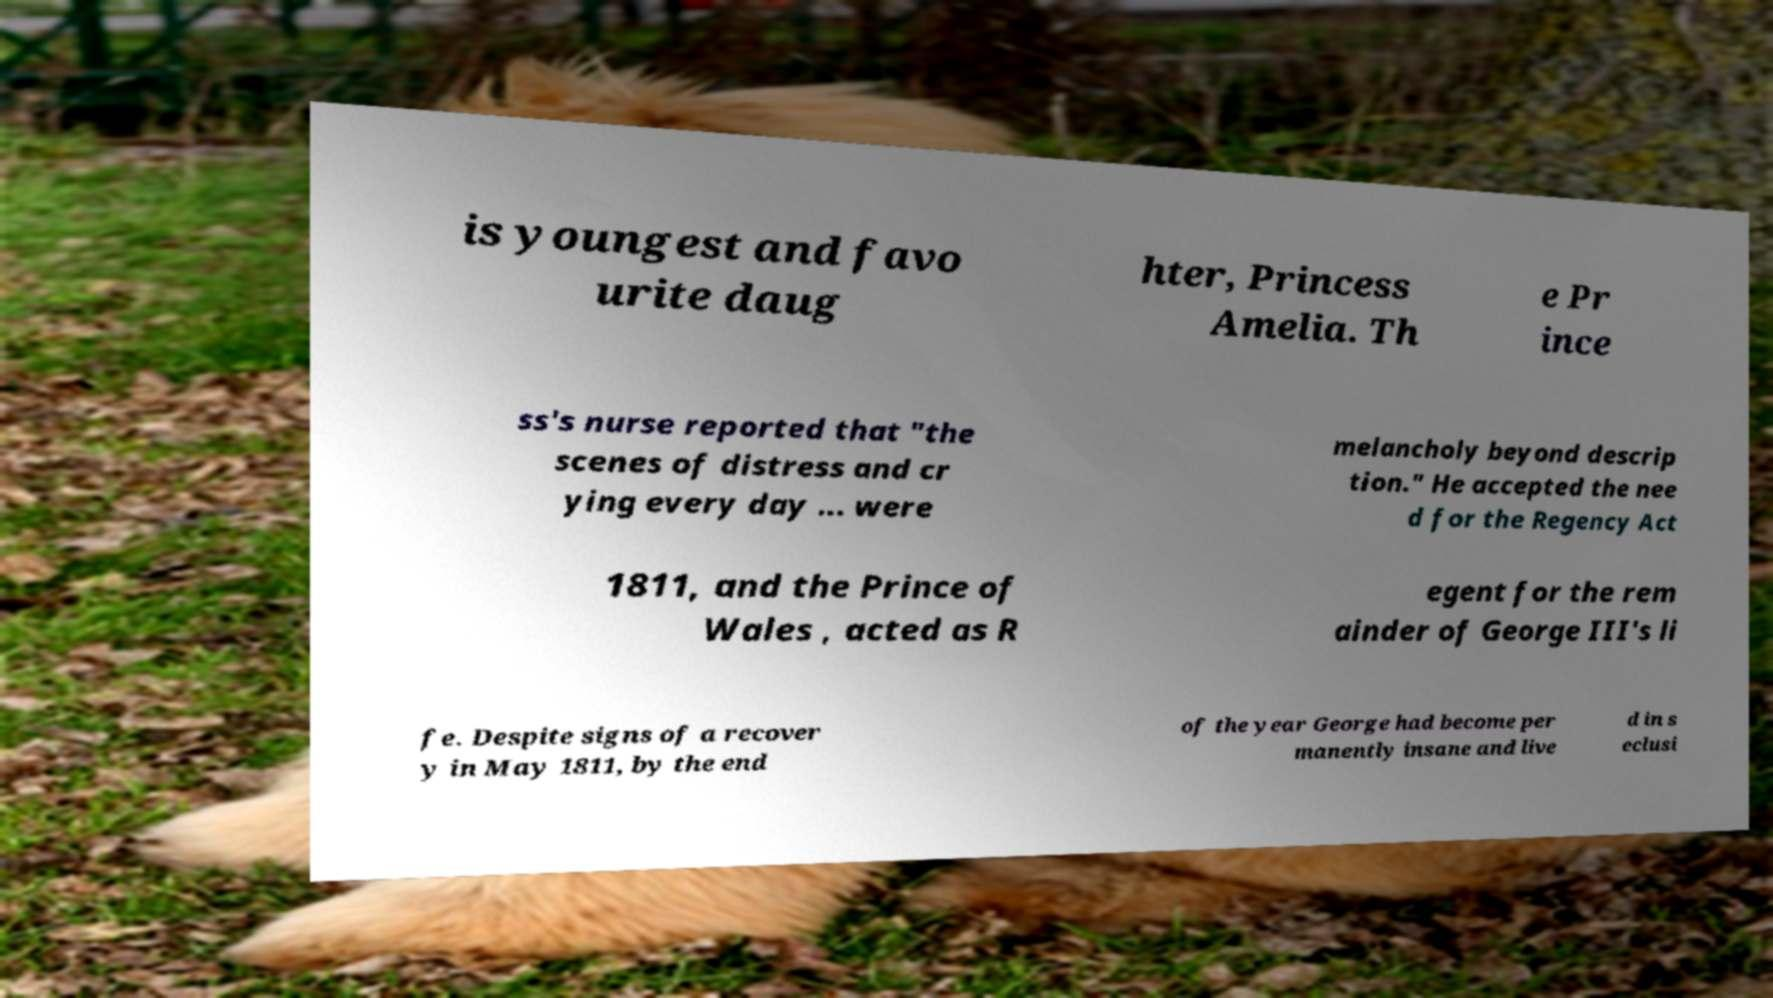Can you accurately transcribe the text from the provided image for me? is youngest and favo urite daug hter, Princess Amelia. Th e Pr ince ss's nurse reported that "the scenes of distress and cr ying every day ... were melancholy beyond descrip tion." He accepted the nee d for the Regency Act 1811, and the Prince of Wales , acted as R egent for the rem ainder of George III's li fe. Despite signs of a recover y in May 1811, by the end of the year George had become per manently insane and live d in s eclusi 